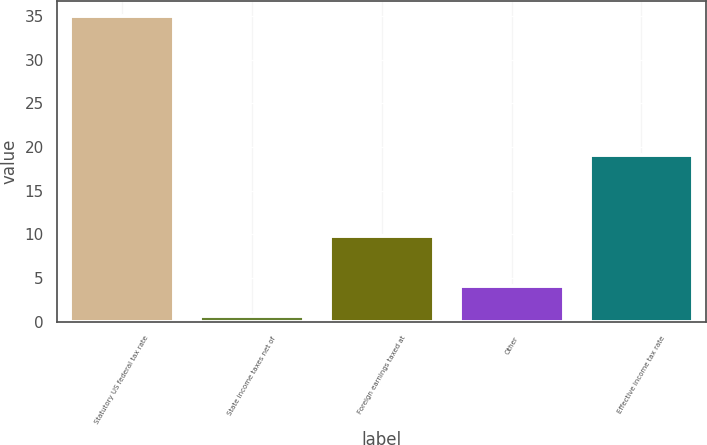Convert chart to OTSL. <chart><loc_0><loc_0><loc_500><loc_500><bar_chart><fcel>Statutory US federal tax rate<fcel>State income taxes net of<fcel>Foreign earnings taxed at<fcel>Other<fcel>Effective income tax rate<nl><fcel>35<fcel>0.7<fcel>9.8<fcel>4.13<fcel>19.1<nl></chart> 